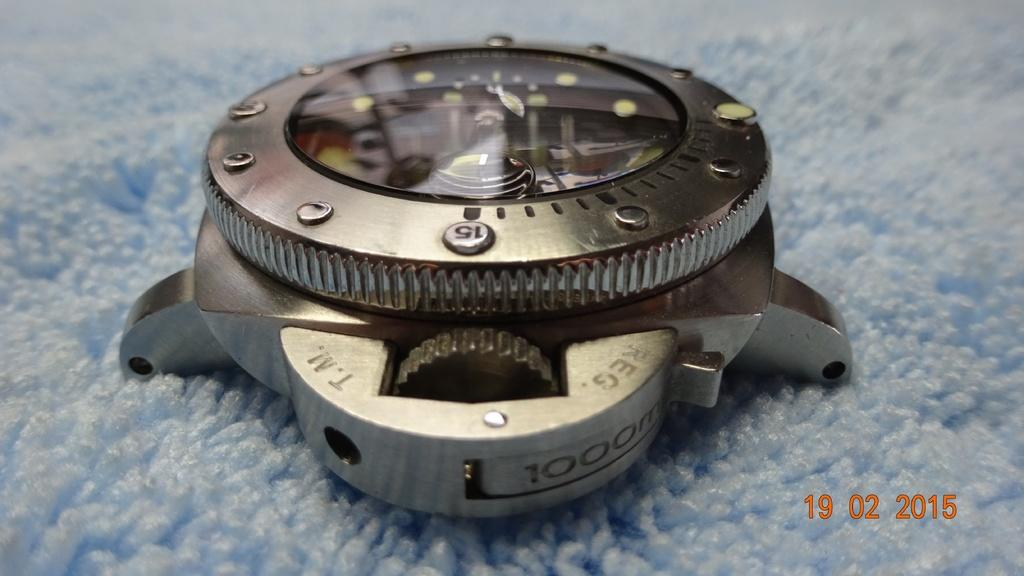<image>
Offer a succinct explanation of the picture presented. Face of a watch which has the number 1000 on the bottom. 